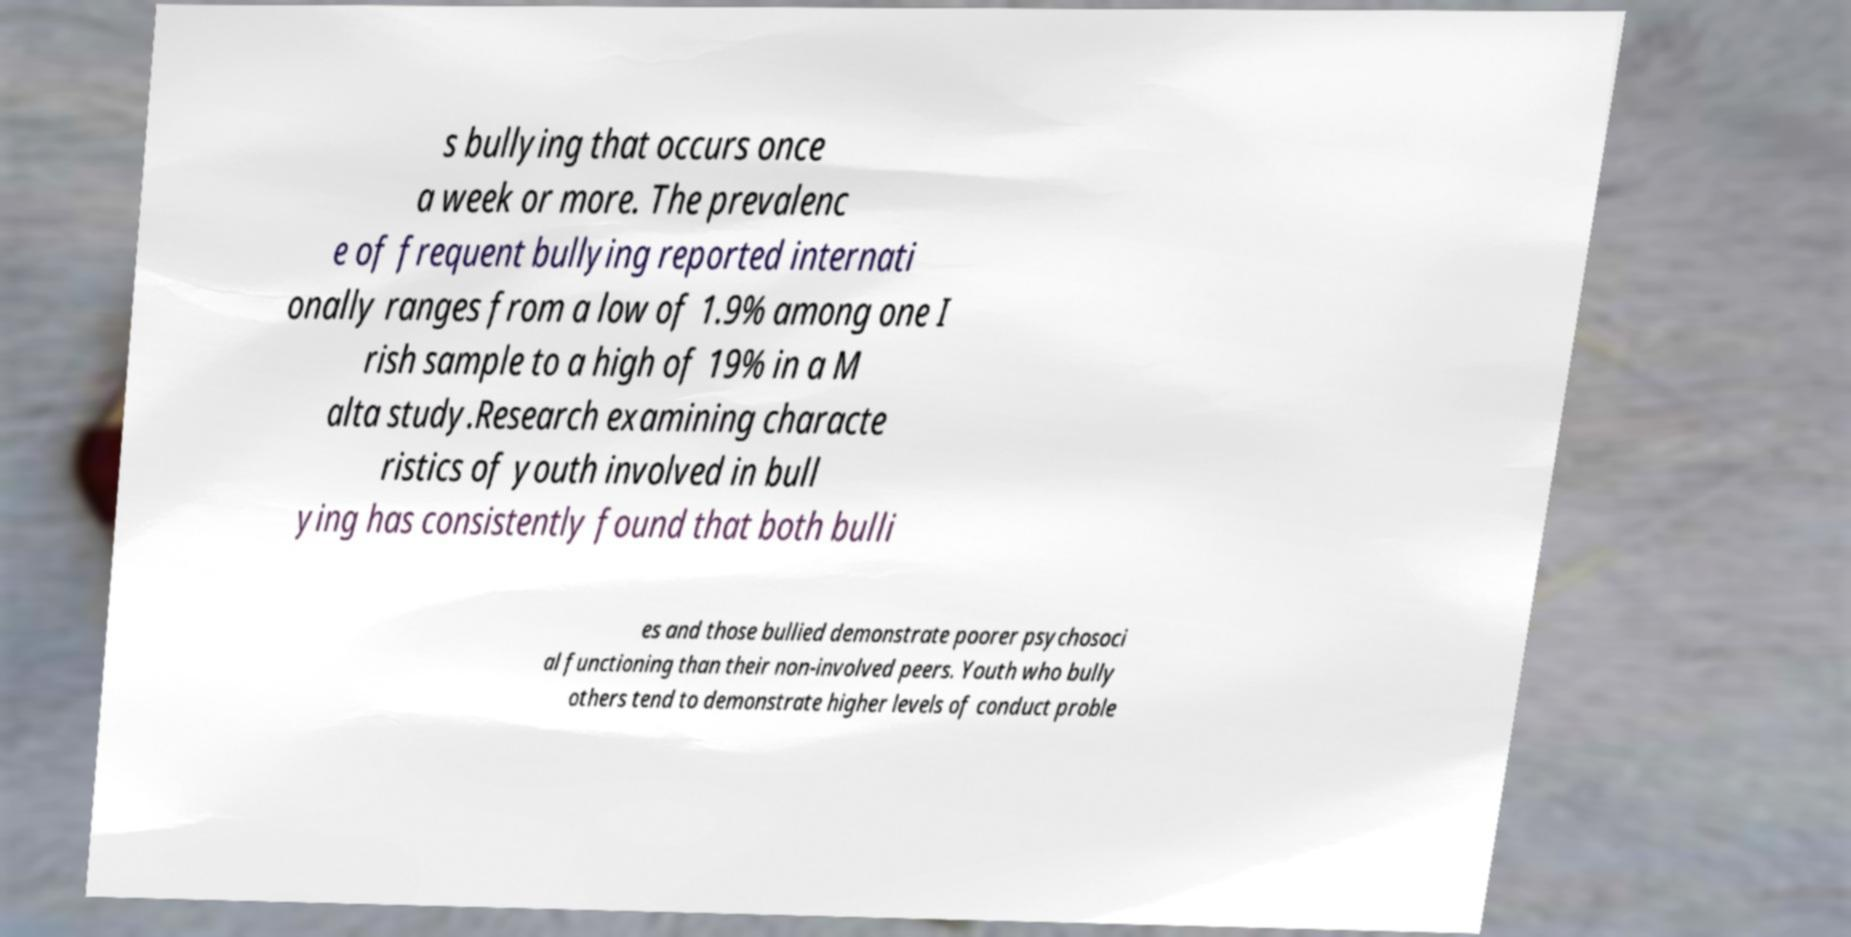Please read and relay the text visible in this image. What does it say? s bullying that occurs once a week or more. The prevalenc e of frequent bullying reported internati onally ranges from a low of 1.9% among one I rish sample to a high of 19% in a M alta study.Research examining characte ristics of youth involved in bull ying has consistently found that both bulli es and those bullied demonstrate poorer psychosoci al functioning than their non-involved peers. Youth who bully others tend to demonstrate higher levels of conduct proble 